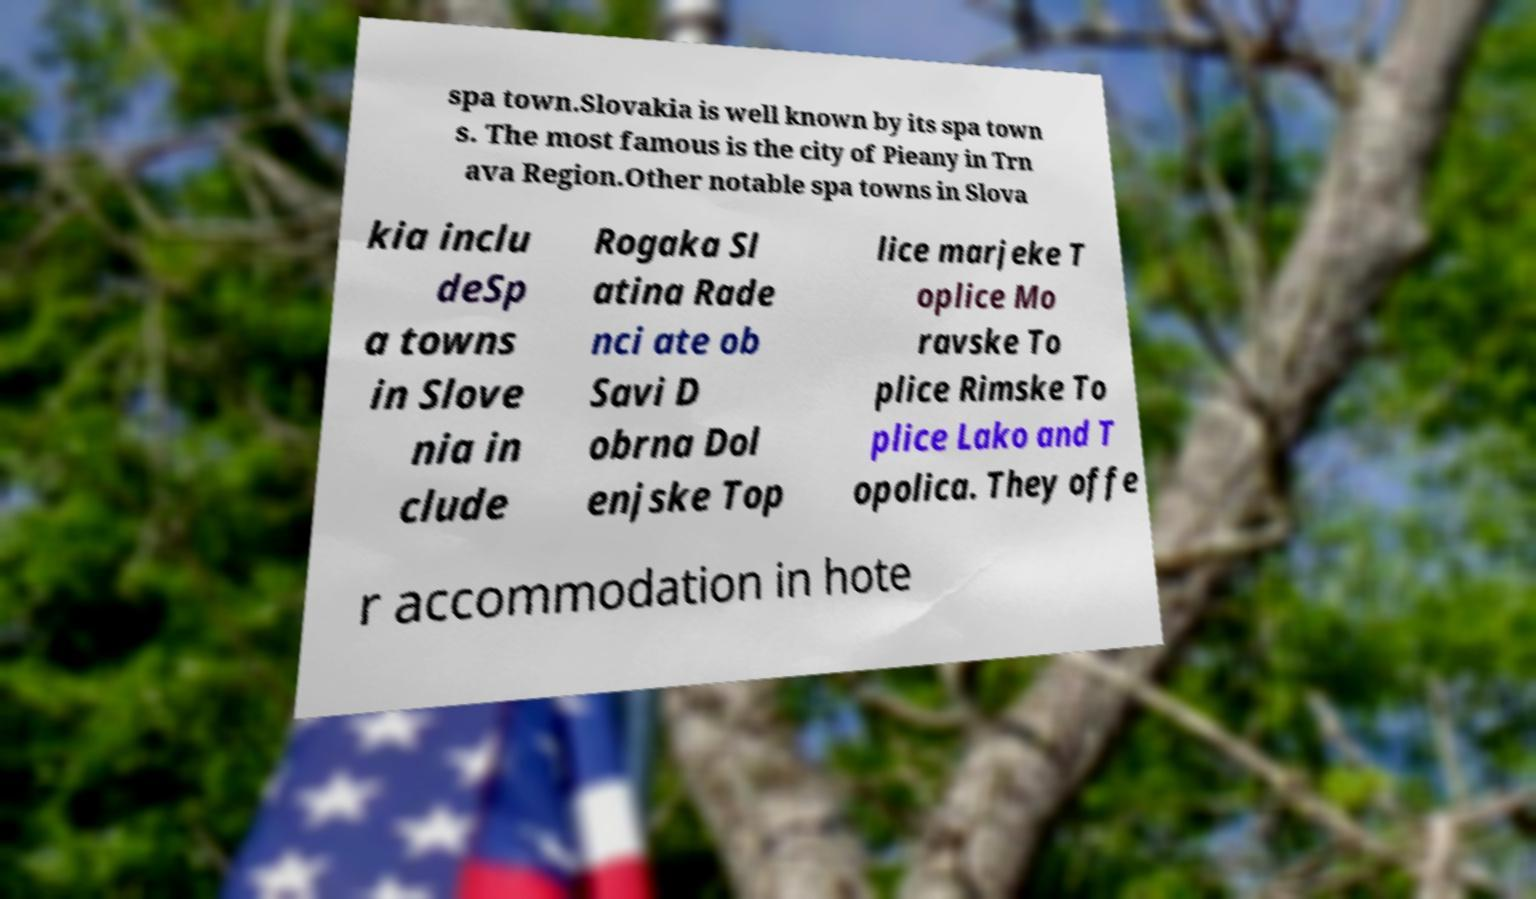Could you assist in decoding the text presented in this image and type it out clearly? spa town.Slovakia is well known by its spa town s. The most famous is the city of Pieany in Trn ava Region.Other notable spa towns in Slova kia inclu deSp a towns in Slove nia in clude Rogaka Sl atina Rade nci ate ob Savi D obrna Dol enjske Top lice marjeke T oplice Mo ravske To plice Rimske To plice Lako and T opolica. They offe r accommodation in hote 